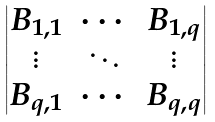Convert formula to latex. <formula><loc_0><loc_0><loc_500><loc_500>\begin{vmatrix} B _ { 1 , 1 } & \cdots & B _ { 1 , q } \\ \vdots & \ddots & \vdots \\ B _ { q , 1 } & \cdots & B _ { q , q } \end{vmatrix}</formula> 